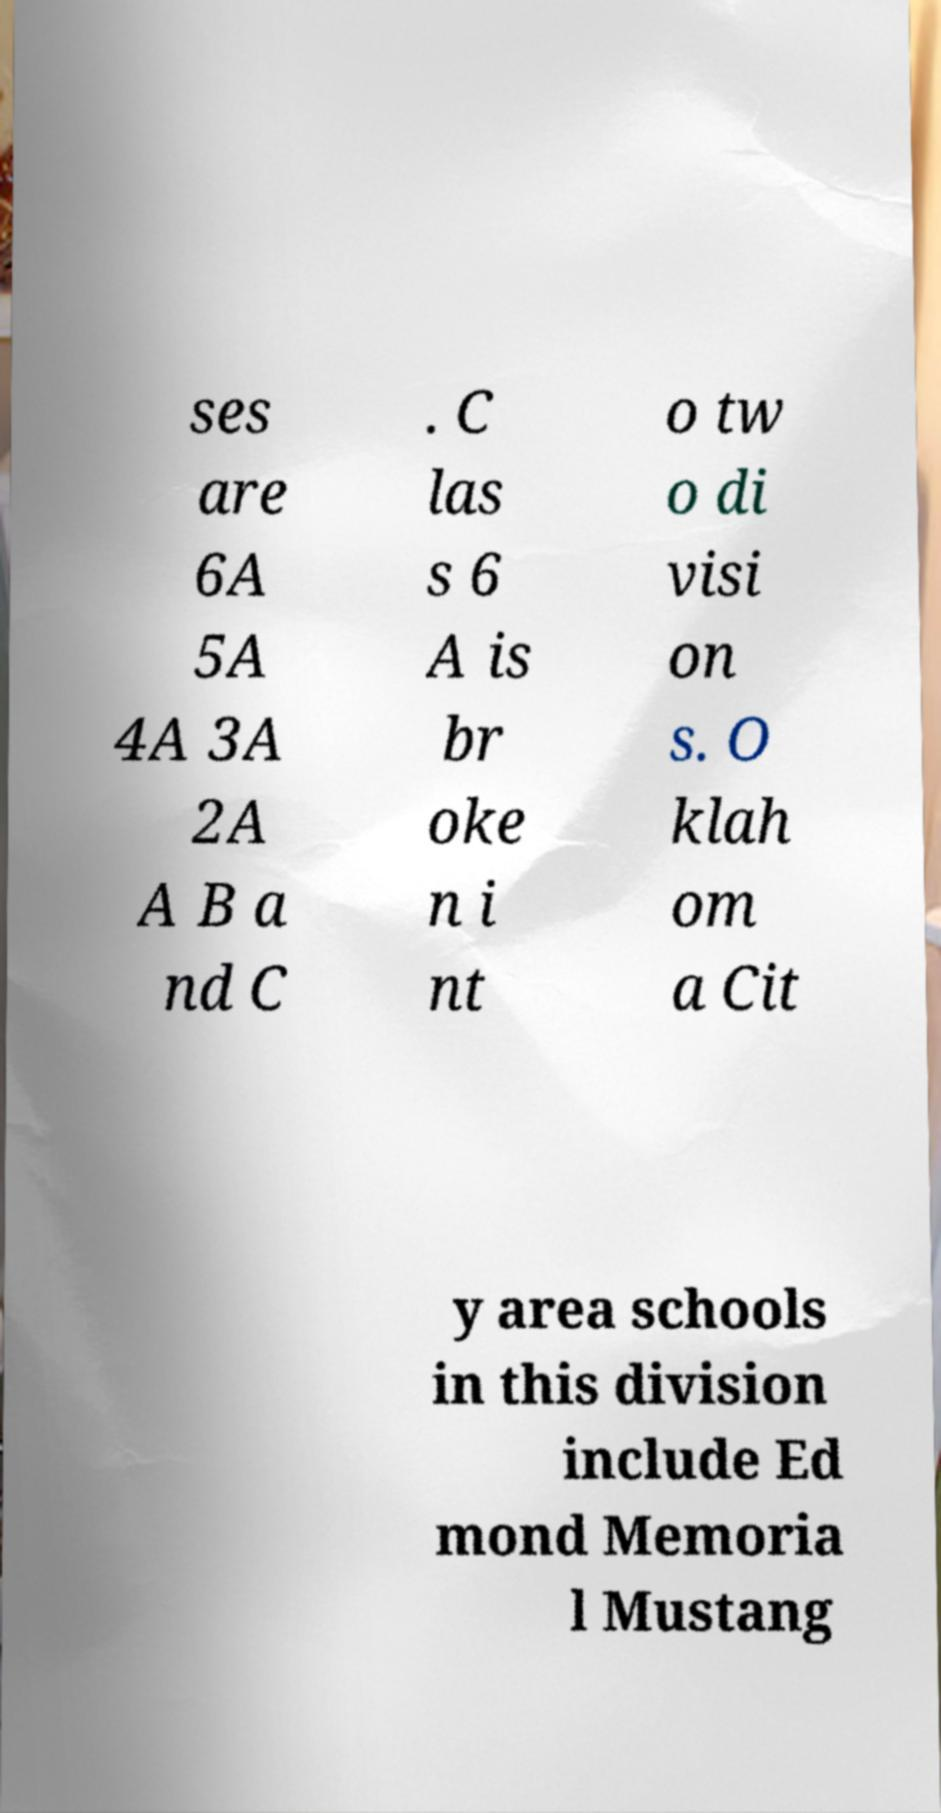Please identify and transcribe the text found in this image. ses are 6A 5A 4A 3A 2A A B a nd C . C las s 6 A is br oke n i nt o tw o di visi on s. O klah om a Cit y area schools in this division include Ed mond Memoria l Mustang 